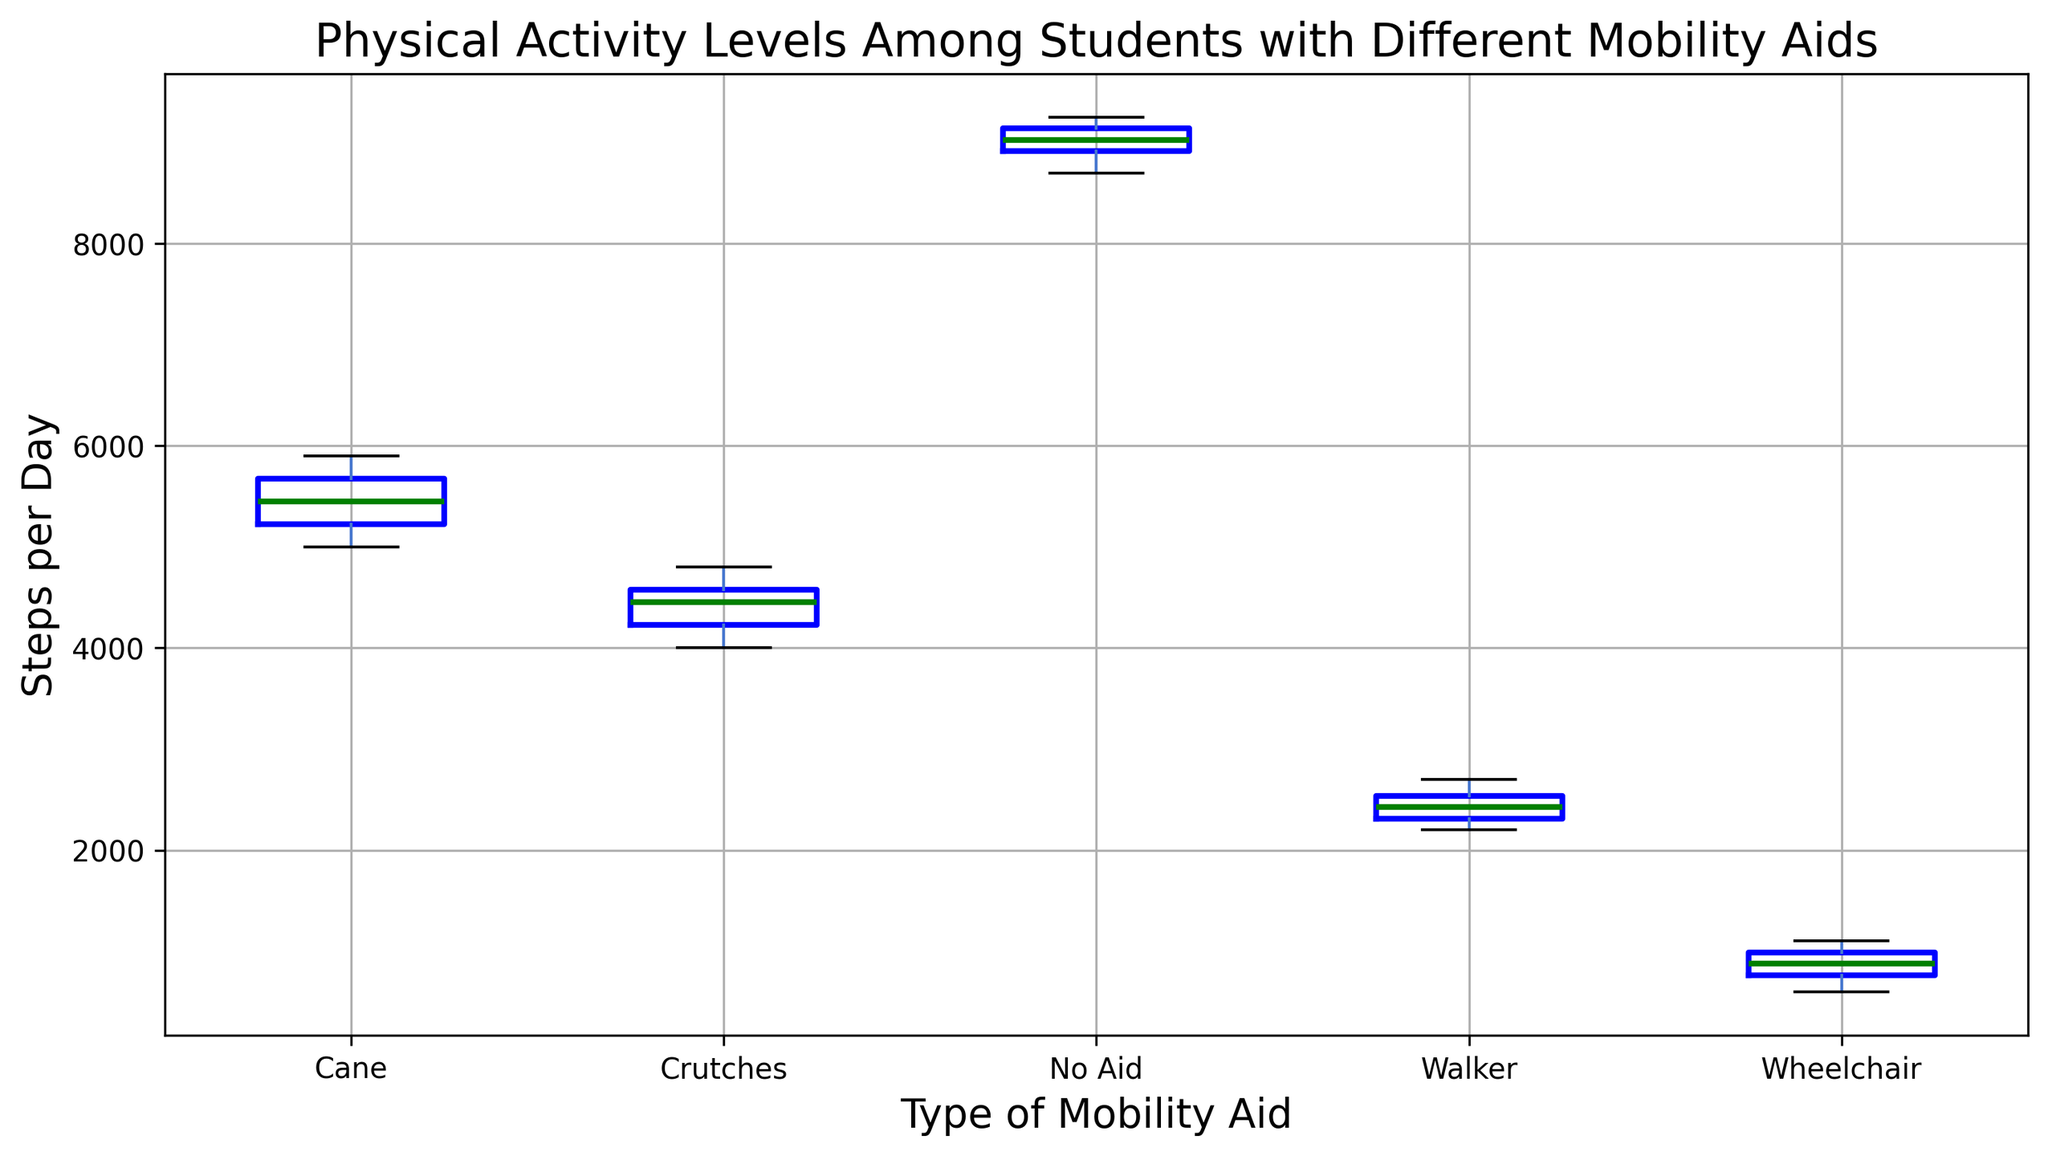What type of mobility aid has the highest median steps per day? To find the highest median steps per day, look for the line inside the box that represents the median value. Compare these medians for each mobility aid.
Answer: No Aid Which type of mobility aid has the widest interquartile range (IQR) in steps per day? The IQR is the distance between the first quartile (bottom of the box) and third quartile (top of the box). Find the mobility aid with the biggest box length.
Answer: Cane Are the median steps per day for students using a wheelchair higher or lower than those using crutches? Compare the median lines inside the boxes for wheelchair and crutches.
Answer: Lower What is the approximate range of steps per day for students using a walker? The range is the distance between the smallest and largest values. Find the minimum (bottom whisker) and maximum (top whisker) points for the walker.
Answer: 2200 to 2700 What is the interquartile range (IQR) of steps per day for students using a cane? The IQR is the difference between the first quartile and third quartile values. Identify these points (bottom and top of the box) for the cane and subtract them.
Answer: Approximately 620 Among the types of mobility aids, which has the smallest spread in the total steps per day? Spread can be viewed from the length of the whiskers. Look for the mobility aid with the shortest whiskers.
Answer: Walker Is the highest individual step count observed among students using a wheelchair greater than the lowest step count of students using crutches? Compare the highest point (top whisker) of wheelchair to the lowest point (bottom whisker) of crutches.
Answer: No Which type of mobility aid has the most outliers? Outliers are marked with a different symbol (e.g., red + signs). Count these markers for each type of mobility aid.
Answer: Crutches Does any type of mobility aid have overlapping quartile ranges with another? Check where the boxes for different mobility aids overlap in height.
Answer: Yes What is the difference between the median steps per day for students using no aid and those using a walker? Find the median lines for no aid and walker and subtract the lower from the higher. The no aid median is significantly higher.
Answer: Approximately 6500 steps 